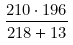<formula> <loc_0><loc_0><loc_500><loc_500>\frac { 2 1 0 \cdot 1 9 6 } { 2 1 8 + 1 3 }</formula> 